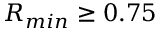<formula> <loc_0><loc_0><loc_500><loc_500>R _ { \min } \geq 0 . 7 5</formula> 